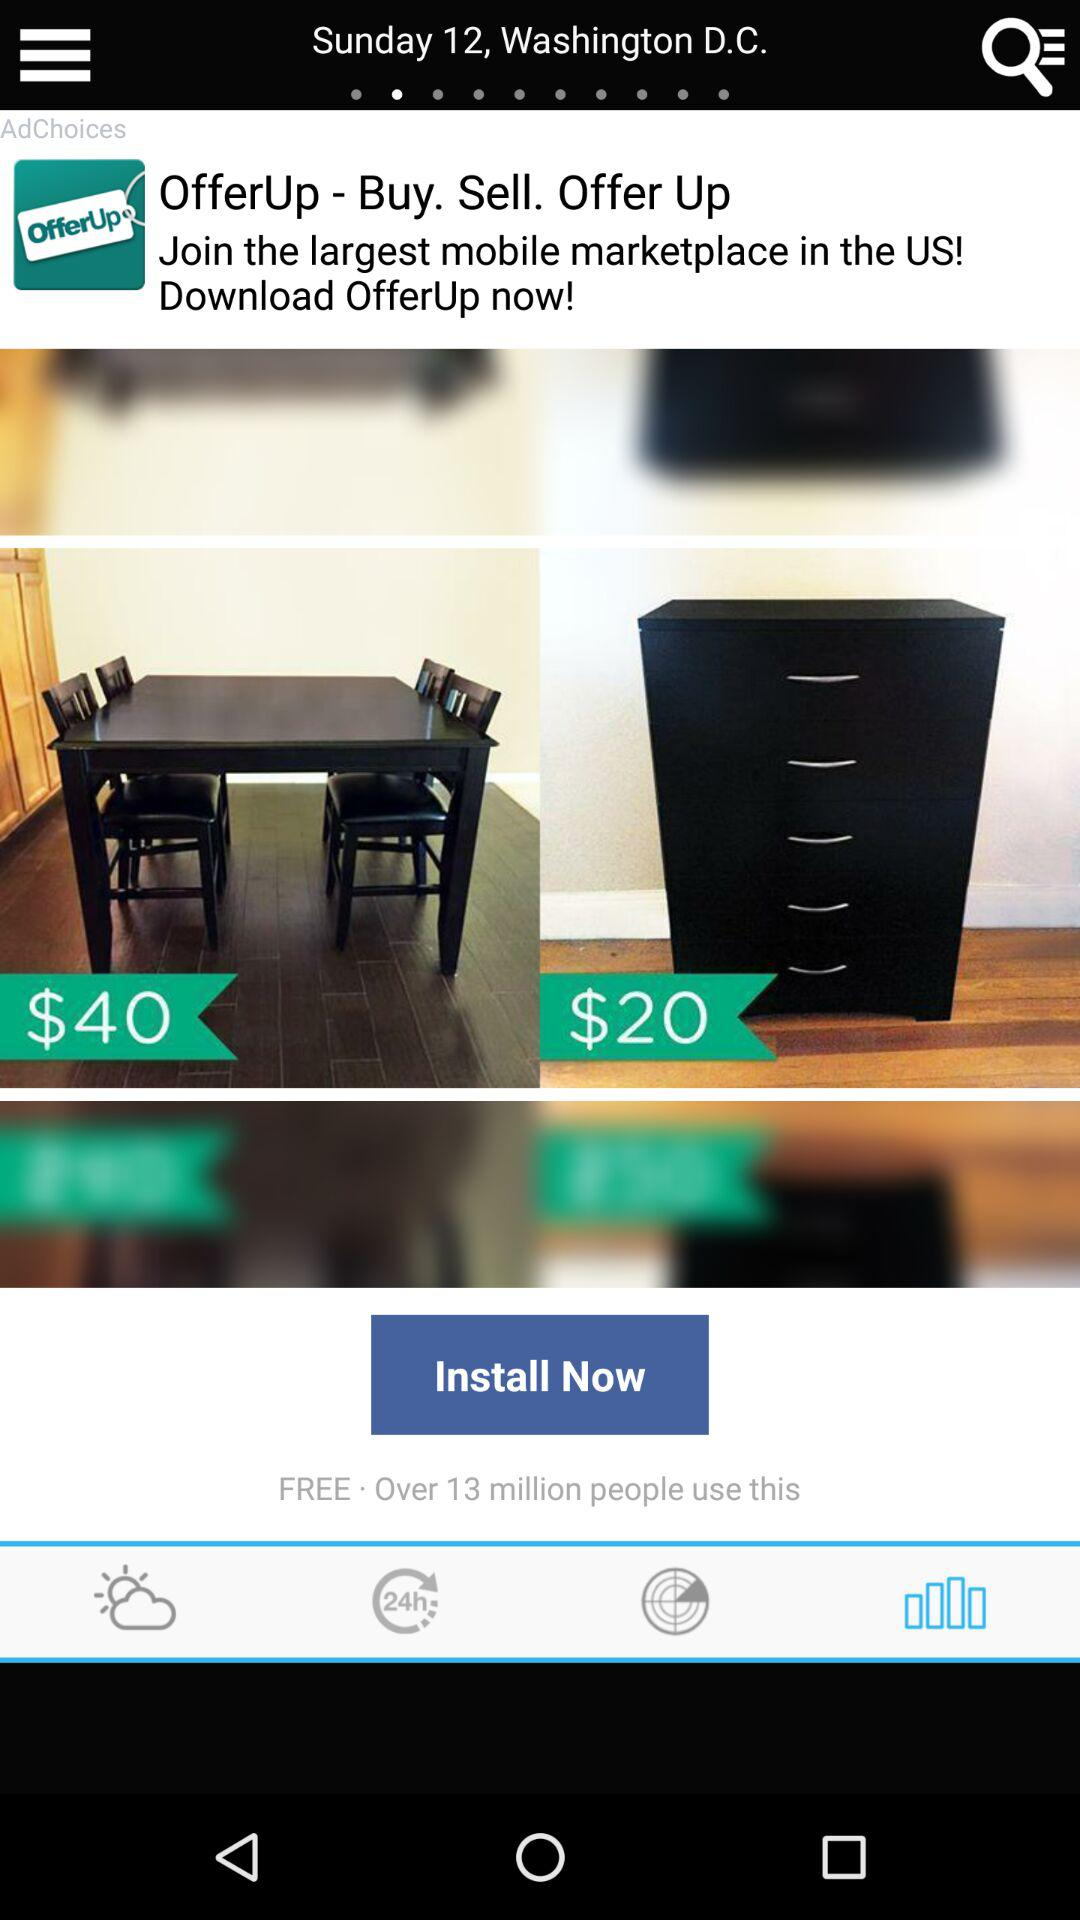What time is it?
When the provided information is insufficient, respond with <no answer>. <no answer> 